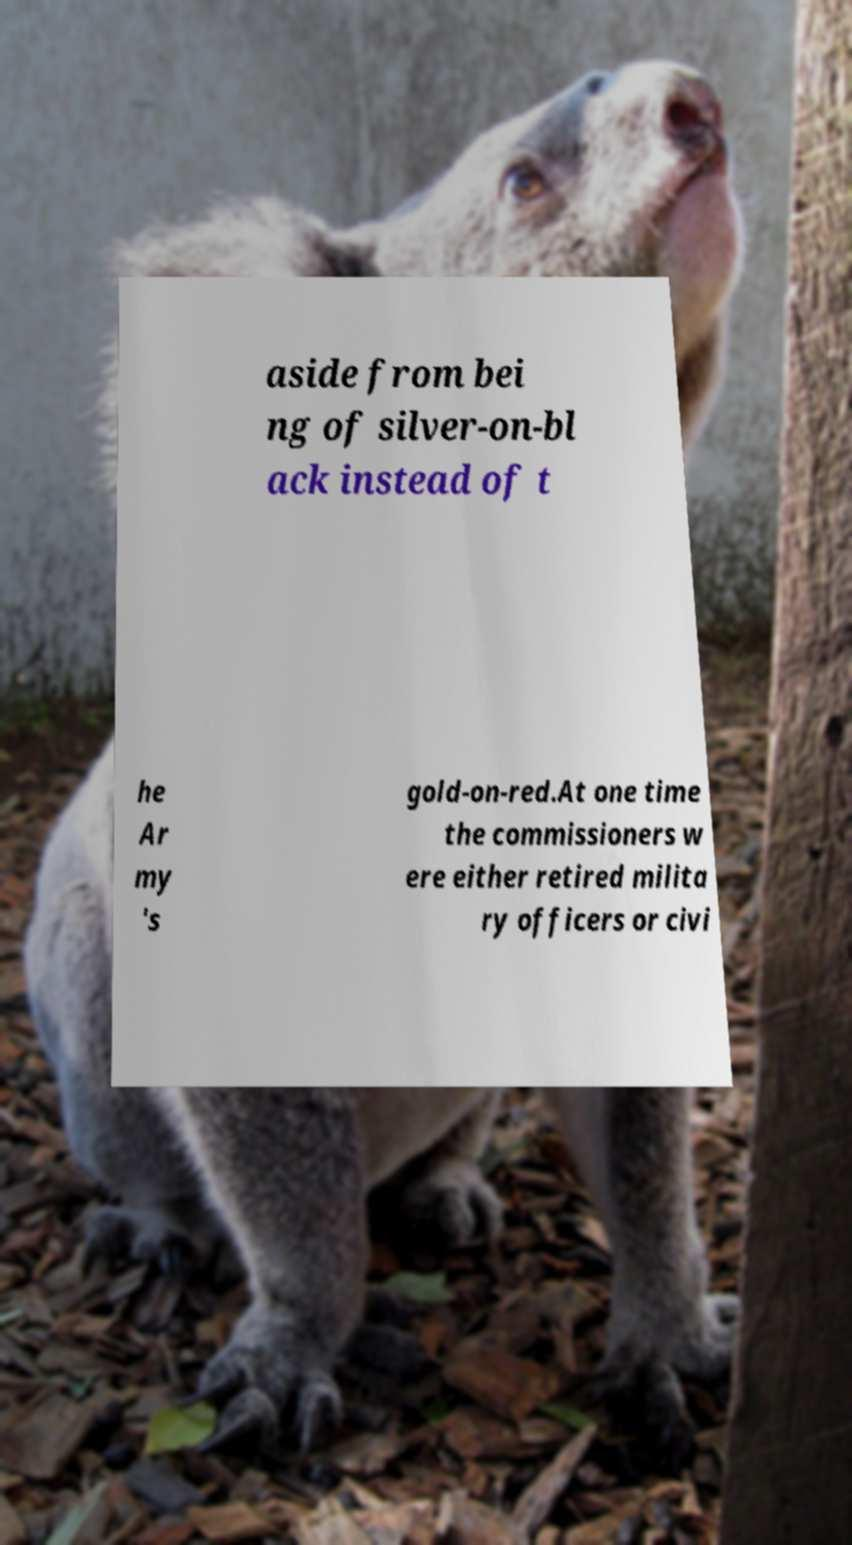Please read and relay the text visible in this image. What does it say? aside from bei ng of silver-on-bl ack instead of t he Ar my 's gold-on-red.At one time the commissioners w ere either retired milita ry officers or civi 